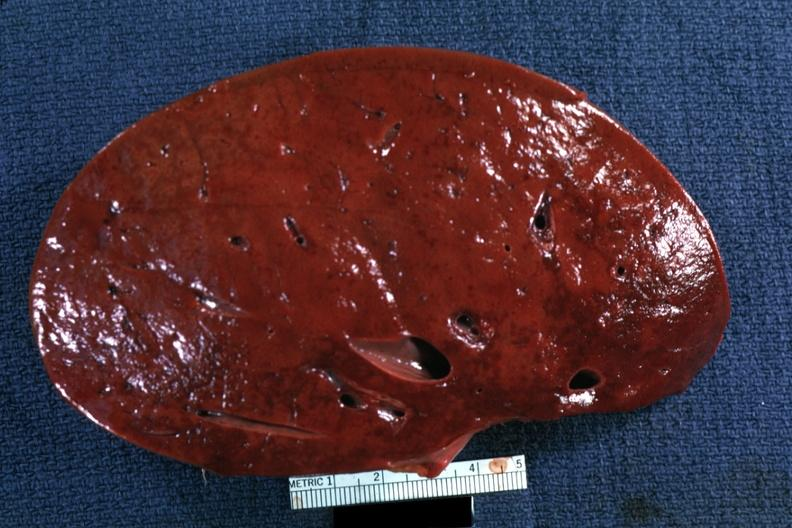what had?
Answer the question using a single word or phrase. This person 